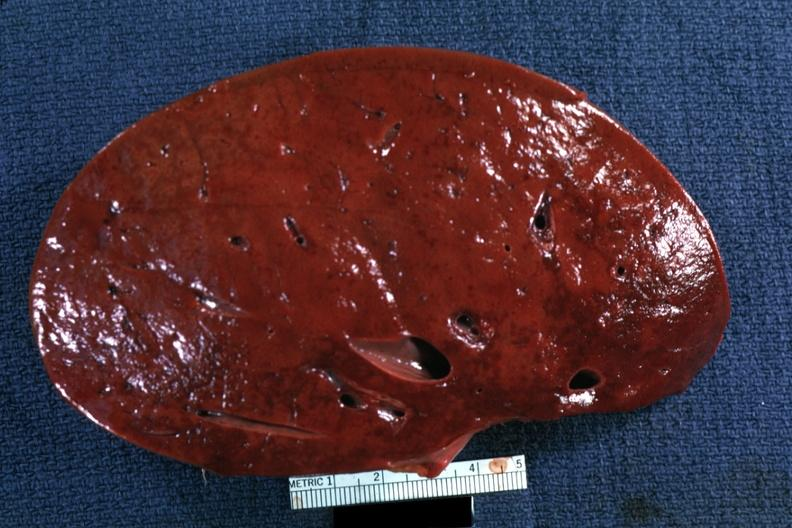what had?
Answer the question using a single word or phrase. This person 